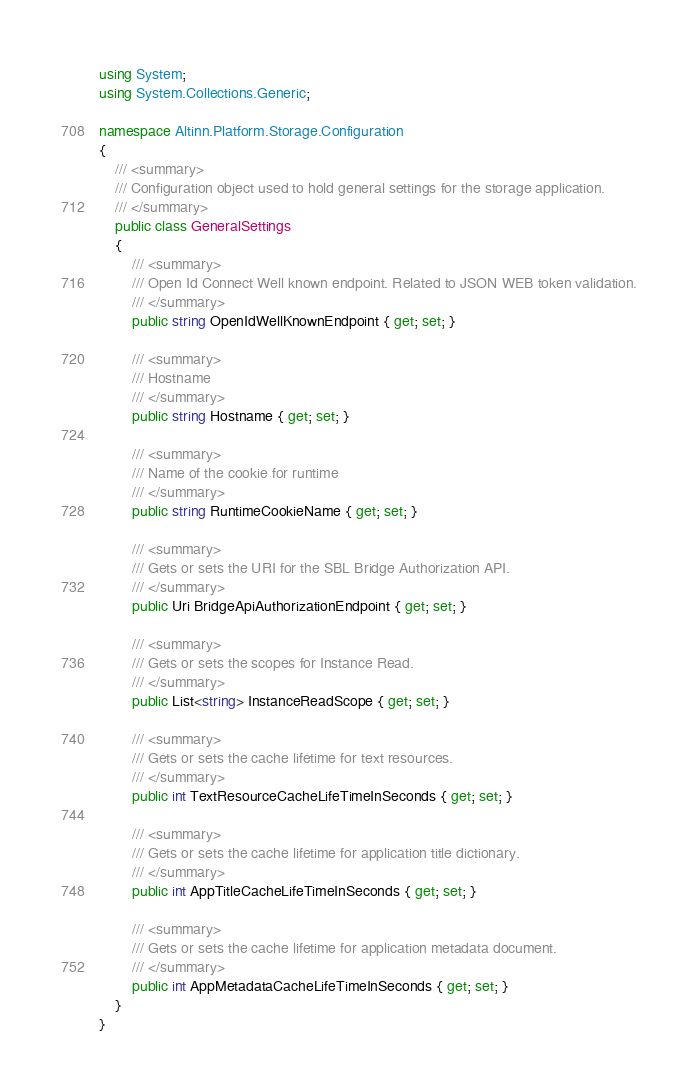<code> <loc_0><loc_0><loc_500><loc_500><_C#_>using System;
using System.Collections.Generic;

namespace Altinn.Platform.Storage.Configuration
{
    /// <summary>
    /// Configuration object used to hold general settings for the storage application.
    /// </summary>
    public class GeneralSettings
    {
        /// <summary>
        /// Open Id Connect Well known endpoint. Related to JSON WEB token validation.
        /// </summary>
        public string OpenIdWellKnownEndpoint { get; set; }

        /// <summary>
        /// Hostname
        /// </summary>
        public string Hostname { get; set; }

        /// <summary>
        /// Name of the cookie for runtime
        /// </summary>
        public string RuntimeCookieName { get; set; }

        /// <summary>
        /// Gets or sets the URI for the SBL Bridge Authorization API.
        /// </summary>
        public Uri BridgeApiAuthorizationEndpoint { get; set; }

        /// <summary>
        /// Gets or sets the scopes for Instance Read.
        /// </summary>
        public List<string> InstanceReadScope { get; set; }

        /// <summary>
        /// Gets or sets the cache lifetime for text resources.
        /// </summary>
        public int TextResourceCacheLifeTimeInSeconds { get; set; }

        /// <summary>
        /// Gets or sets the cache lifetime for application title dictionary.
        /// </summary>
        public int AppTitleCacheLifeTimeInSeconds { get; set; }

        /// <summary>
        /// Gets or sets the cache lifetime for application metadata document.
        /// </summary>
        public int AppMetadataCacheLifeTimeInSeconds { get; set; }
    }
}
</code> 